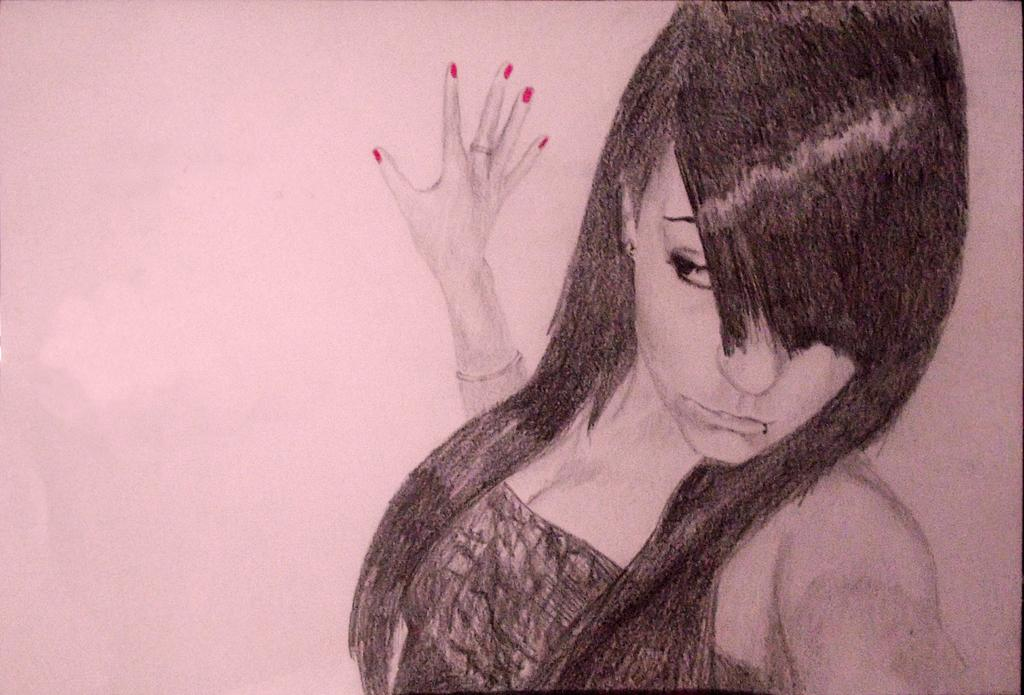What is the woman in the image doing? The woman is sketching. What is the color of the surface the woman is sketching on? The surface the woman is sketching on is white. What type of celery is being distributed on the steel surface in the image? There is no celery or steel surface present in the image; it features a woman sketching on a white surface. 